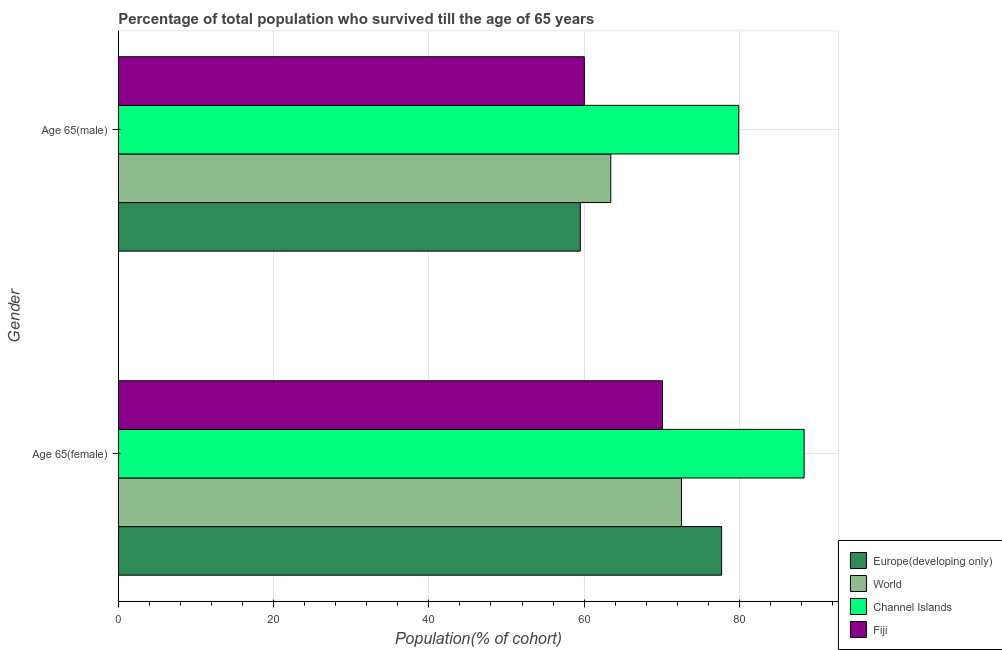How many different coloured bars are there?
Ensure brevity in your answer.  4. How many groups of bars are there?
Provide a succinct answer. 2. How many bars are there on the 2nd tick from the top?
Offer a very short reply. 4. What is the label of the 2nd group of bars from the top?
Your answer should be compact. Age 65(female). What is the percentage of male population who survived till age of 65 in Fiji?
Offer a terse response. 60.03. Across all countries, what is the maximum percentage of female population who survived till age of 65?
Provide a short and direct response. 88.34. Across all countries, what is the minimum percentage of female population who survived till age of 65?
Provide a succinct answer. 70.1. In which country was the percentage of female population who survived till age of 65 maximum?
Make the answer very short. Channel Islands. In which country was the percentage of female population who survived till age of 65 minimum?
Provide a succinct answer. Fiji. What is the total percentage of male population who survived till age of 65 in the graph?
Your answer should be very brief. 262.89. What is the difference between the percentage of female population who survived till age of 65 in World and that in Fiji?
Your answer should be very brief. 2.45. What is the difference between the percentage of male population who survived till age of 65 in Channel Islands and the percentage of female population who survived till age of 65 in Europe(developing only)?
Ensure brevity in your answer.  2.2. What is the average percentage of male population who survived till age of 65 per country?
Your answer should be very brief. 65.72. What is the difference between the percentage of male population who survived till age of 65 and percentage of female population who survived till age of 65 in Europe(developing only)?
Your response must be concise. -18.21. In how many countries, is the percentage of female population who survived till age of 65 greater than 40 %?
Give a very brief answer. 4. What is the ratio of the percentage of male population who survived till age of 65 in Channel Islands to that in Europe(developing only)?
Your response must be concise. 1.34. What does the 4th bar from the top in Age 65(male) represents?
Provide a succinct answer. Europe(developing only). What does the 1st bar from the bottom in Age 65(female) represents?
Your response must be concise. Europe(developing only). How many bars are there?
Keep it short and to the point. 8. What is the difference between two consecutive major ticks on the X-axis?
Keep it short and to the point. 20. Are the values on the major ticks of X-axis written in scientific E-notation?
Offer a terse response. No. Does the graph contain grids?
Your answer should be very brief. Yes. Where does the legend appear in the graph?
Ensure brevity in your answer.  Bottom right. How many legend labels are there?
Offer a very short reply. 4. How are the legend labels stacked?
Provide a short and direct response. Vertical. What is the title of the graph?
Your answer should be very brief. Percentage of total population who survived till the age of 65 years. What is the label or title of the X-axis?
Provide a short and direct response. Population(% of cohort). What is the label or title of the Y-axis?
Offer a terse response. Gender. What is the Population(% of cohort) of Europe(developing only) in Age 65(female)?
Provide a short and direct response. 77.71. What is the Population(% of cohort) of World in Age 65(female)?
Keep it short and to the point. 72.54. What is the Population(% of cohort) in Channel Islands in Age 65(female)?
Your answer should be very brief. 88.34. What is the Population(% of cohort) of Fiji in Age 65(female)?
Give a very brief answer. 70.1. What is the Population(% of cohort) of Europe(developing only) in Age 65(male)?
Make the answer very short. 59.51. What is the Population(% of cohort) in World in Age 65(male)?
Your answer should be very brief. 63.44. What is the Population(% of cohort) of Channel Islands in Age 65(male)?
Offer a terse response. 79.92. What is the Population(% of cohort) of Fiji in Age 65(male)?
Your answer should be compact. 60.03. Across all Gender, what is the maximum Population(% of cohort) of Europe(developing only)?
Offer a very short reply. 77.71. Across all Gender, what is the maximum Population(% of cohort) in World?
Provide a short and direct response. 72.54. Across all Gender, what is the maximum Population(% of cohort) of Channel Islands?
Ensure brevity in your answer.  88.34. Across all Gender, what is the maximum Population(% of cohort) of Fiji?
Offer a terse response. 70.1. Across all Gender, what is the minimum Population(% of cohort) of Europe(developing only)?
Give a very brief answer. 59.51. Across all Gender, what is the minimum Population(% of cohort) of World?
Your answer should be very brief. 63.44. Across all Gender, what is the minimum Population(% of cohort) in Channel Islands?
Ensure brevity in your answer.  79.92. Across all Gender, what is the minimum Population(% of cohort) in Fiji?
Your answer should be compact. 60.03. What is the total Population(% of cohort) in Europe(developing only) in the graph?
Offer a very short reply. 137.22. What is the total Population(% of cohort) of World in the graph?
Offer a very short reply. 135.98. What is the total Population(% of cohort) in Channel Islands in the graph?
Offer a very short reply. 168.26. What is the total Population(% of cohort) of Fiji in the graph?
Give a very brief answer. 130.13. What is the difference between the Population(% of cohort) of Europe(developing only) in Age 65(female) and that in Age 65(male)?
Make the answer very short. 18.21. What is the difference between the Population(% of cohort) in World in Age 65(female) and that in Age 65(male)?
Ensure brevity in your answer.  9.1. What is the difference between the Population(% of cohort) of Channel Islands in Age 65(female) and that in Age 65(male)?
Your response must be concise. 8.42. What is the difference between the Population(% of cohort) in Fiji in Age 65(female) and that in Age 65(male)?
Your answer should be very brief. 10.07. What is the difference between the Population(% of cohort) of Europe(developing only) in Age 65(female) and the Population(% of cohort) of World in Age 65(male)?
Offer a very short reply. 14.28. What is the difference between the Population(% of cohort) of Europe(developing only) in Age 65(female) and the Population(% of cohort) of Channel Islands in Age 65(male)?
Keep it short and to the point. -2.2. What is the difference between the Population(% of cohort) of Europe(developing only) in Age 65(female) and the Population(% of cohort) of Fiji in Age 65(male)?
Your answer should be compact. 17.68. What is the difference between the Population(% of cohort) of World in Age 65(female) and the Population(% of cohort) of Channel Islands in Age 65(male)?
Your answer should be compact. -7.37. What is the difference between the Population(% of cohort) of World in Age 65(female) and the Population(% of cohort) of Fiji in Age 65(male)?
Your response must be concise. 12.51. What is the difference between the Population(% of cohort) of Channel Islands in Age 65(female) and the Population(% of cohort) of Fiji in Age 65(male)?
Provide a short and direct response. 28.31. What is the average Population(% of cohort) of Europe(developing only) per Gender?
Provide a short and direct response. 68.61. What is the average Population(% of cohort) in World per Gender?
Provide a succinct answer. 67.99. What is the average Population(% of cohort) of Channel Islands per Gender?
Your answer should be very brief. 84.13. What is the average Population(% of cohort) of Fiji per Gender?
Your answer should be compact. 65.06. What is the difference between the Population(% of cohort) in Europe(developing only) and Population(% of cohort) in World in Age 65(female)?
Offer a very short reply. 5.17. What is the difference between the Population(% of cohort) of Europe(developing only) and Population(% of cohort) of Channel Islands in Age 65(female)?
Give a very brief answer. -10.63. What is the difference between the Population(% of cohort) of Europe(developing only) and Population(% of cohort) of Fiji in Age 65(female)?
Make the answer very short. 7.62. What is the difference between the Population(% of cohort) in World and Population(% of cohort) in Channel Islands in Age 65(female)?
Offer a terse response. -15.8. What is the difference between the Population(% of cohort) of World and Population(% of cohort) of Fiji in Age 65(female)?
Give a very brief answer. 2.45. What is the difference between the Population(% of cohort) of Channel Islands and Population(% of cohort) of Fiji in Age 65(female)?
Provide a succinct answer. 18.24. What is the difference between the Population(% of cohort) in Europe(developing only) and Population(% of cohort) in World in Age 65(male)?
Ensure brevity in your answer.  -3.93. What is the difference between the Population(% of cohort) of Europe(developing only) and Population(% of cohort) of Channel Islands in Age 65(male)?
Offer a very short reply. -20.41. What is the difference between the Population(% of cohort) of Europe(developing only) and Population(% of cohort) of Fiji in Age 65(male)?
Offer a very short reply. -0.52. What is the difference between the Population(% of cohort) in World and Population(% of cohort) in Channel Islands in Age 65(male)?
Ensure brevity in your answer.  -16.48. What is the difference between the Population(% of cohort) in World and Population(% of cohort) in Fiji in Age 65(male)?
Provide a succinct answer. 3.41. What is the difference between the Population(% of cohort) in Channel Islands and Population(% of cohort) in Fiji in Age 65(male)?
Provide a succinct answer. 19.89. What is the ratio of the Population(% of cohort) of Europe(developing only) in Age 65(female) to that in Age 65(male)?
Your answer should be very brief. 1.31. What is the ratio of the Population(% of cohort) of World in Age 65(female) to that in Age 65(male)?
Ensure brevity in your answer.  1.14. What is the ratio of the Population(% of cohort) in Channel Islands in Age 65(female) to that in Age 65(male)?
Provide a succinct answer. 1.11. What is the ratio of the Population(% of cohort) of Fiji in Age 65(female) to that in Age 65(male)?
Ensure brevity in your answer.  1.17. What is the difference between the highest and the second highest Population(% of cohort) of Europe(developing only)?
Keep it short and to the point. 18.21. What is the difference between the highest and the second highest Population(% of cohort) of World?
Keep it short and to the point. 9.1. What is the difference between the highest and the second highest Population(% of cohort) of Channel Islands?
Your answer should be very brief. 8.42. What is the difference between the highest and the second highest Population(% of cohort) in Fiji?
Provide a succinct answer. 10.07. What is the difference between the highest and the lowest Population(% of cohort) of Europe(developing only)?
Provide a short and direct response. 18.21. What is the difference between the highest and the lowest Population(% of cohort) in World?
Your response must be concise. 9.1. What is the difference between the highest and the lowest Population(% of cohort) of Channel Islands?
Provide a succinct answer. 8.42. What is the difference between the highest and the lowest Population(% of cohort) in Fiji?
Your response must be concise. 10.07. 